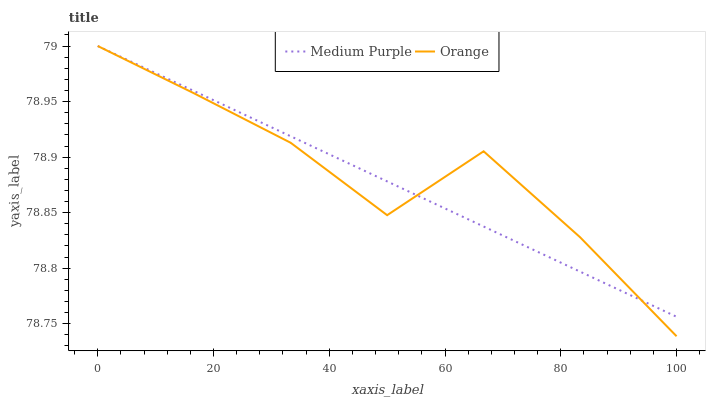Does Medium Purple have the minimum area under the curve?
Answer yes or no. Yes. Does Orange have the maximum area under the curve?
Answer yes or no. Yes. Does Orange have the minimum area under the curve?
Answer yes or no. No. Is Medium Purple the smoothest?
Answer yes or no. Yes. Is Orange the roughest?
Answer yes or no. Yes. Is Orange the smoothest?
Answer yes or no. No. Does Orange have the highest value?
Answer yes or no. Yes. Does Orange intersect Medium Purple?
Answer yes or no. Yes. Is Orange less than Medium Purple?
Answer yes or no. No. Is Orange greater than Medium Purple?
Answer yes or no. No. 